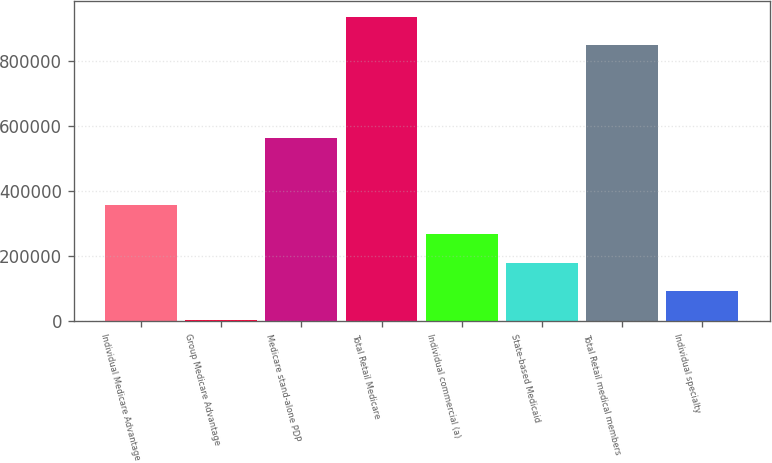<chart> <loc_0><loc_0><loc_500><loc_500><bar_chart><fcel>Individual Medicare Advantage<fcel>Group Medicare Advantage<fcel>Medicare stand-alone PDP<fcel>Total Retail Medicare<fcel>Individual commercial (a)<fcel>State-based Medicaid<fcel>Total Retail medical members<fcel>Individual specialty<nl><fcel>356880<fcel>5600<fcel>563900<fcel>938120<fcel>269060<fcel>181240<fcel>850300<fcel>93420<nl></chart> 